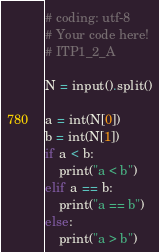Convert code to text. <code><loc_0><loc_0><loc_500><loc_500><_Python_># coding: utf-8
# Your code here!
# ITP1_2_A

N = input().split()

a = int(N[0])
b = int(N[1])
if a < b:
    print("a < b")
elif a == b:
    print("a == b")
else:
    print("a > b")
</code> 